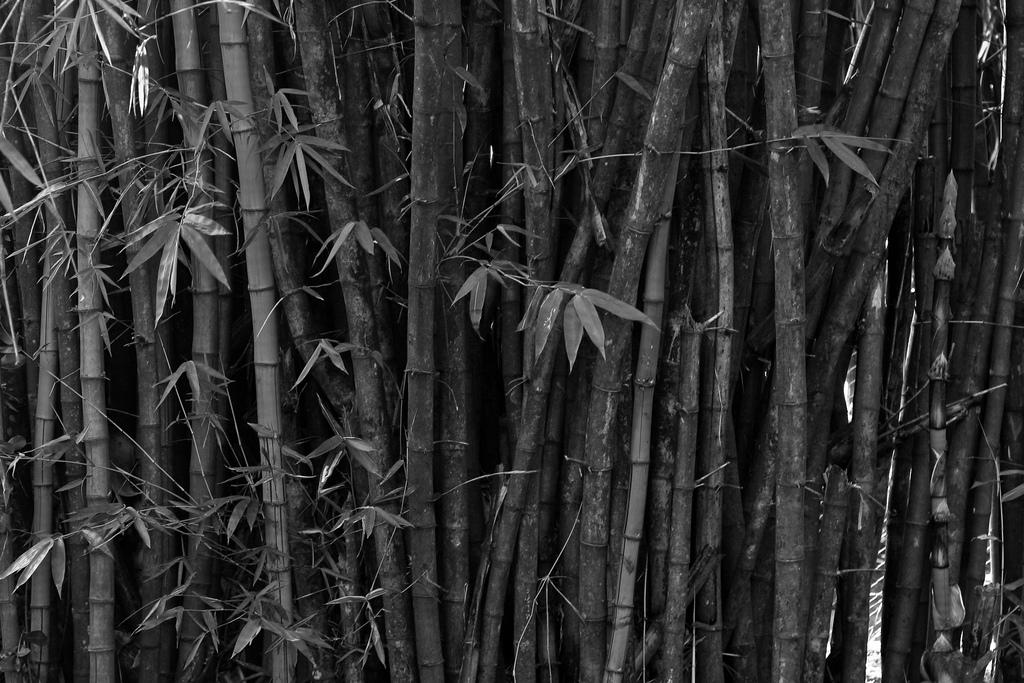What type of plant can be seen in the image? There is bamboo in the image. What other natural elements can be seen in the image? There are leaves in the image. What type of fruit is being cooked in the image? There is no fruit or cooking activity present in the image. Where is the meeting taking place in the image? There is no meeting or indication of a meeting location in the image. 